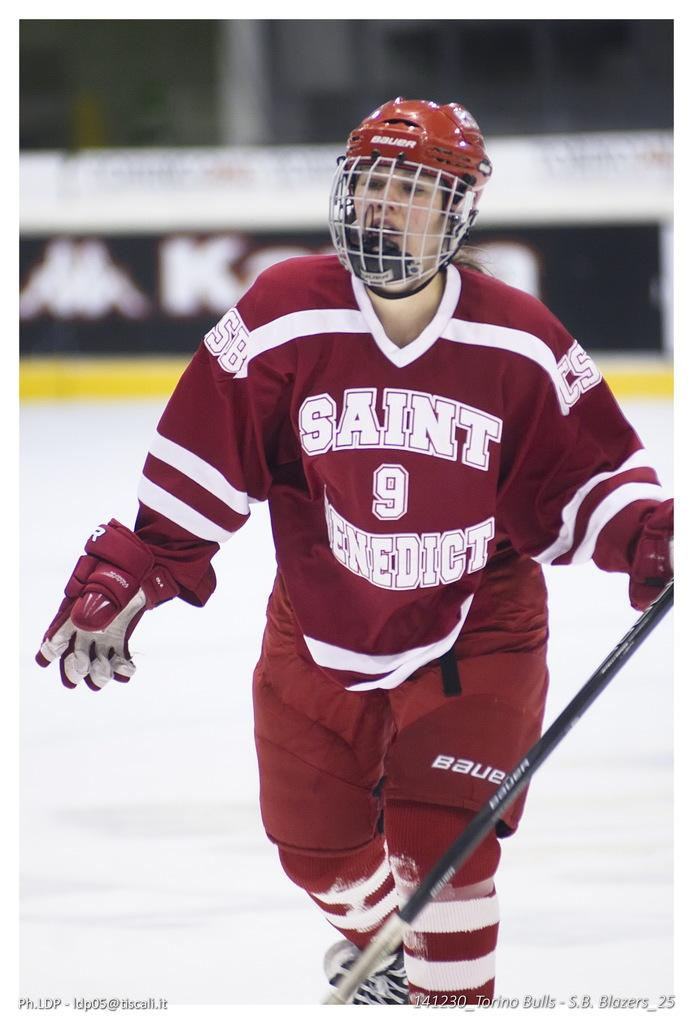Who is the main subject in the image? There is a woman in the image. What is the woman holding in her hand? The woman is holding a stick. What protective gear is the woman wearing? The woman is wearing a helmet and gloves. Can you describe the background of the image? The background of the image is blurred. What hobbies does the scarecrow in the image enjoy? There is no scarecrow present in the image; it features a woman holding a stick and wearing protective gear. What is the value of the item the woman is holding in the image? The value of the stick the woman is holding cannot be determined from the image alone. 